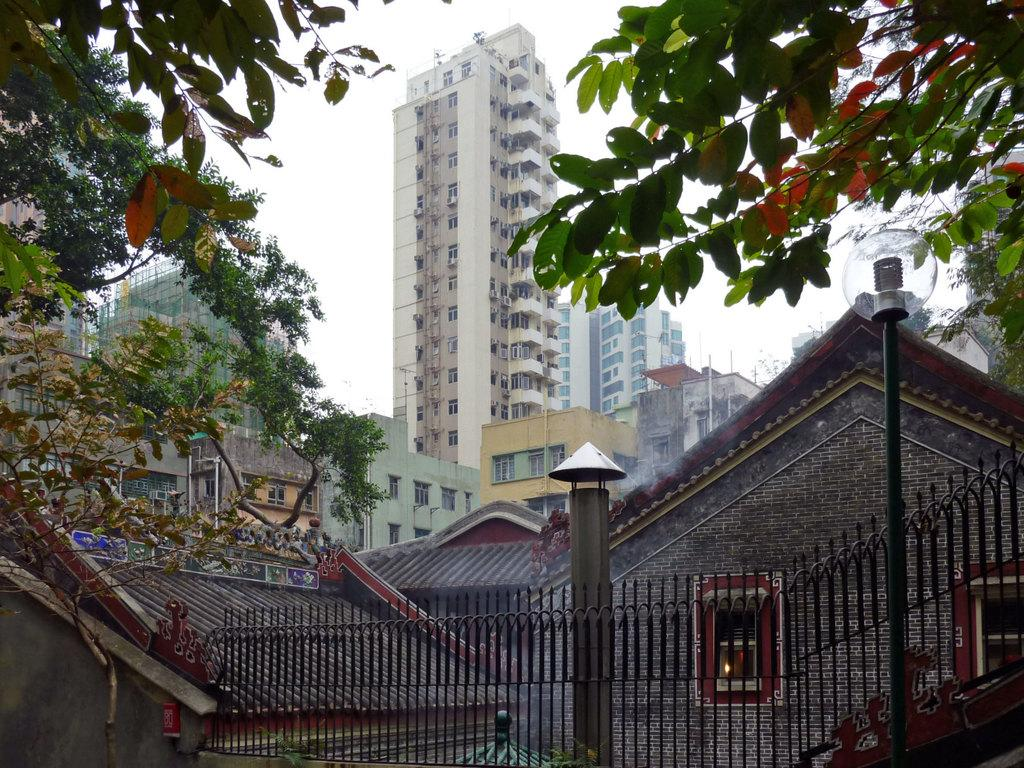What type of structures are present in the image? There are many buildings in the image. What feature do the buildings have in common? The buildings have windows. What type of barrier can be seen in the image? There is a fence in the image. What type of vertical structure is present in the image? There is a light pole in the image. What type of vegetation is present in the image? There are trees in the image. What part of the natural environment is visible in the image? The sky is visible in the image. How many members are on the team that is playing in the image? There is no team or any indication of a game being played in the image. 